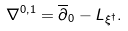<formula> <loc_0><loc_0><loc_500><loc_500>\nabla ^ { 0 , 1 } = \overline { \partial } _ { 0 } - L _ { \xi ^ { \dagger } } .</formula> 